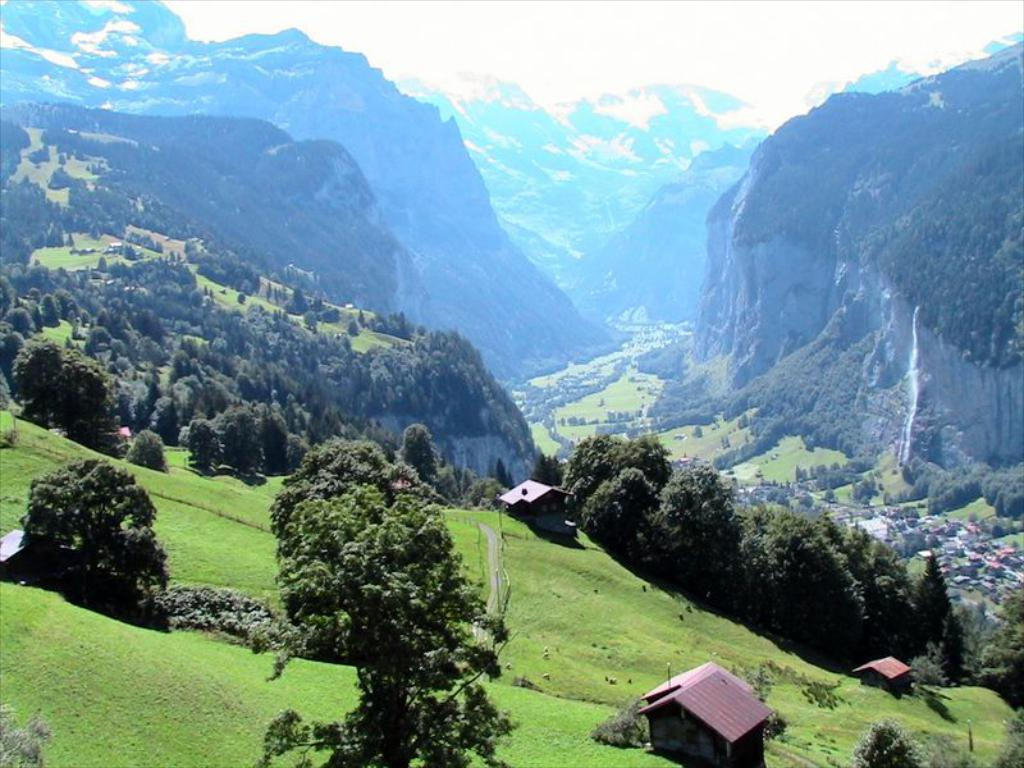What type of natural formation can be seen in the image? There are mountains in the image. What else is present in the image besides the mountains? There are buildings and trees in the image. How is the weather in the image? The sky is clear in the image. What is the condition of the mountains in the image? There is snow on the mountains in the image. How much does the bee weigh in the image? There is no bee present in the image, so its weight cannot be determined. What is the level of anger displayed by the mountains in the image? The mountains do not display emotions like anger; they are inanimate natural formations. 